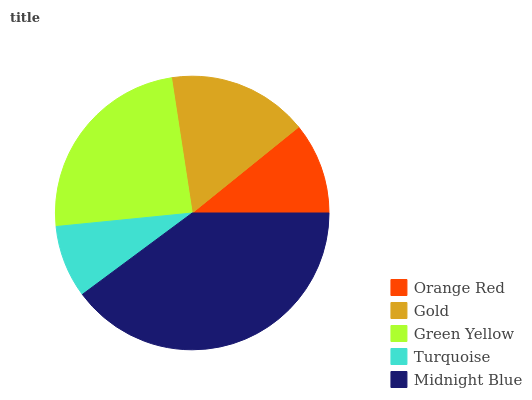Is Turquoise the minimum?
Answer yes or no. Yes. Is Midnight Blue the maximum?
Answer yes or no. Yes. Is Gold the minimum?
Answer yes or no. No. Is Gold the maximum?
Answer yes or no. No. Is Gold greater than Orange Red?
Answer yes or no. Yes. Is Orange Red less than Gold?
Answer yes or no. Yes. Is Orange Red greater than Gold?
Answer yes or no. No. Is Gold less than Orange Red?
Answer yes or no. No. Is Gold the high median?
Answer yes or no. Yes. Is Gold the low median?
Answer yes or no. Yes. Is Orange Red the high median?
Answer yes or no. No. Is Green Yellow the low median?
Answer yes or no. No. 